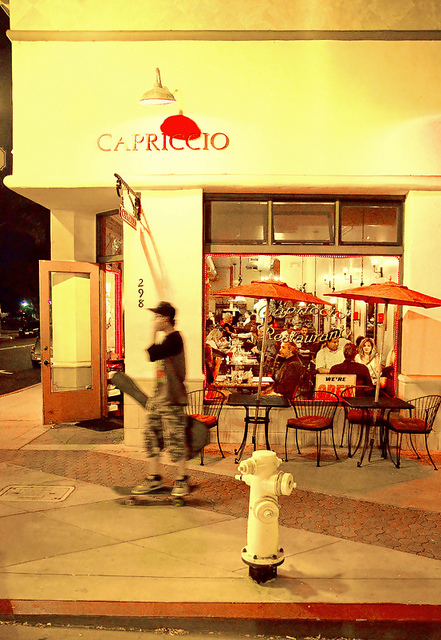Identify and read out the text in this image. CAPRICCIO 298 WE'RE 